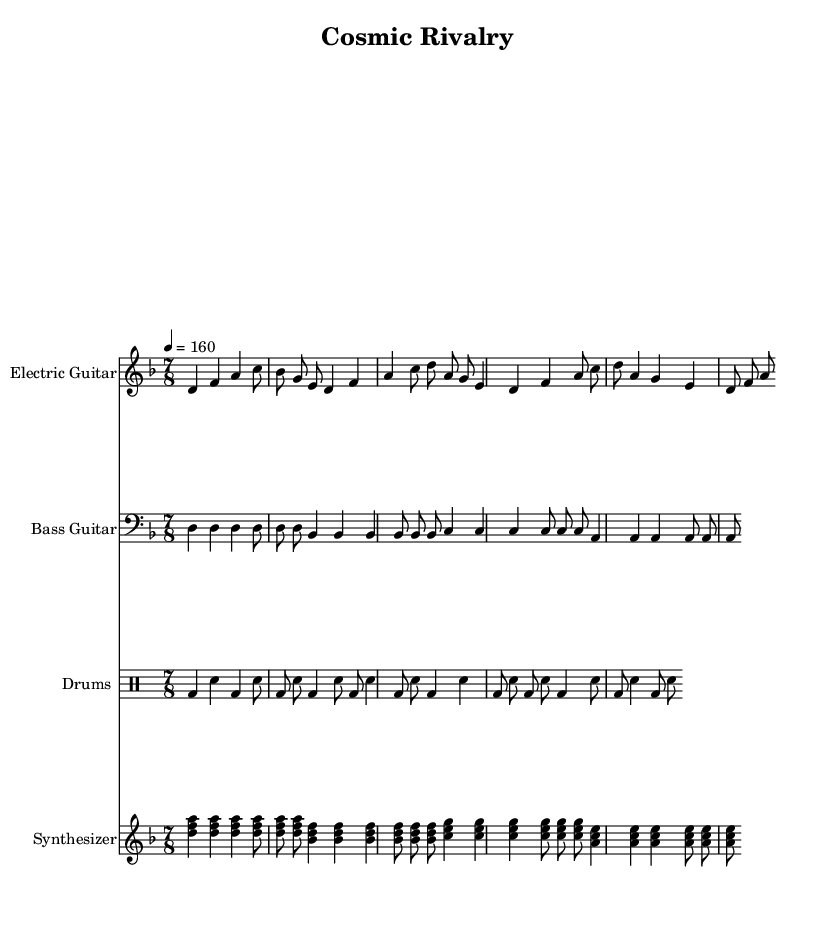What is the key signature of this music? The key signature is indicated at the beginning of the score, which has one flat (B♭), representing D minor.
Answer: D minor What is the time signature of the piece? The time signature is shown at the beginning of the score and is written as 7/8, indicating there are seven eighth notes per measure.
Answer: 7/8 What is the tempo marking given for the piece? The tempo marking is provided in beats per minute and states 4 = 160, meaning there are 160 beats per minute with a quarter note receiving one beat.
Answer: 160 How many measures are shown for the Electric Guitar? By counting the measures in the electric guitar staff, there are a total of 8 distinct measures.
Answer: 8 Which instrument plays the synthesizer? The synthesizer is indicated in the score as having its own staff specifically labeled below the title.
Answer: Synthesizer What theme does the song explore based on the lyrics? By analyzing the lyrics, the song discusses themes related to the space race and technological advancements during the Cold War.
Answer: Space race themes How many distinct parts are there in the drum section? The drum section shows a repeating pattern, but upon examination, there are four unique measures in total within the piece.
Answer: 4 